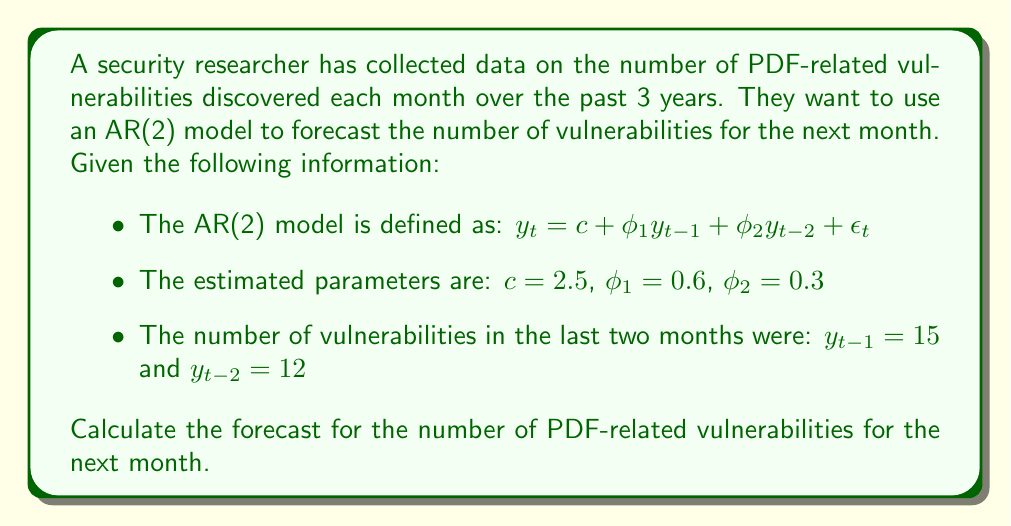Help me with this question. To forecast the number of PDF-related vulnerabilities for the next month using the AR(2) model, we need to follow these steps:

1. Recall the AR(2) model equation:
   $y_t = c + \phi_1 y_{t-1} + \phi_2 y_{t-2} + \epsilon_t$

2. We are given the following parameters:
   $c = 2.5$
   $\phi_1 = 0.6$
   $\phi_2 = 0.3$
   $y_{t-1} = 15$
   $y_{t-2} = 12$

3. For forecasting, we assume that the error term $\epsilon_t = 0$, as it represents the unpredictable part of the model.

4. Substitute the given values into the equation:
   $y_t = 2.5 + 0.6(15) + 0.3(12) + 0$

5. Calculate each term:
   $y_t = 2.5 + 9 + 3.6 + 0$

6. Sum up the terms:
   $y_t = 15.1$

7. Since we're dealing with vulnerabilities, which are discrete counts, we round to the nearest integer:
   $y_t \approx 15$

Therefore, the forecast for the number of PDF-related vulnerabilities for the next month is 15.
Answer: 15 vulnerabilities 